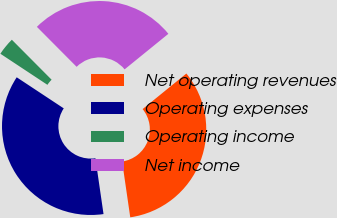Convert chart to OTSL. <chart><loc_0><loc_0><loc_500><loc_500><pie_chart><fcel>Net operating revenues<fcel>Operating expenses<fcel>Operating income<fcel>Net income<nl><fcel>33.56%<fcel>36.59%<fcel>3.25%<fcel>26.6%<nl></chart> 